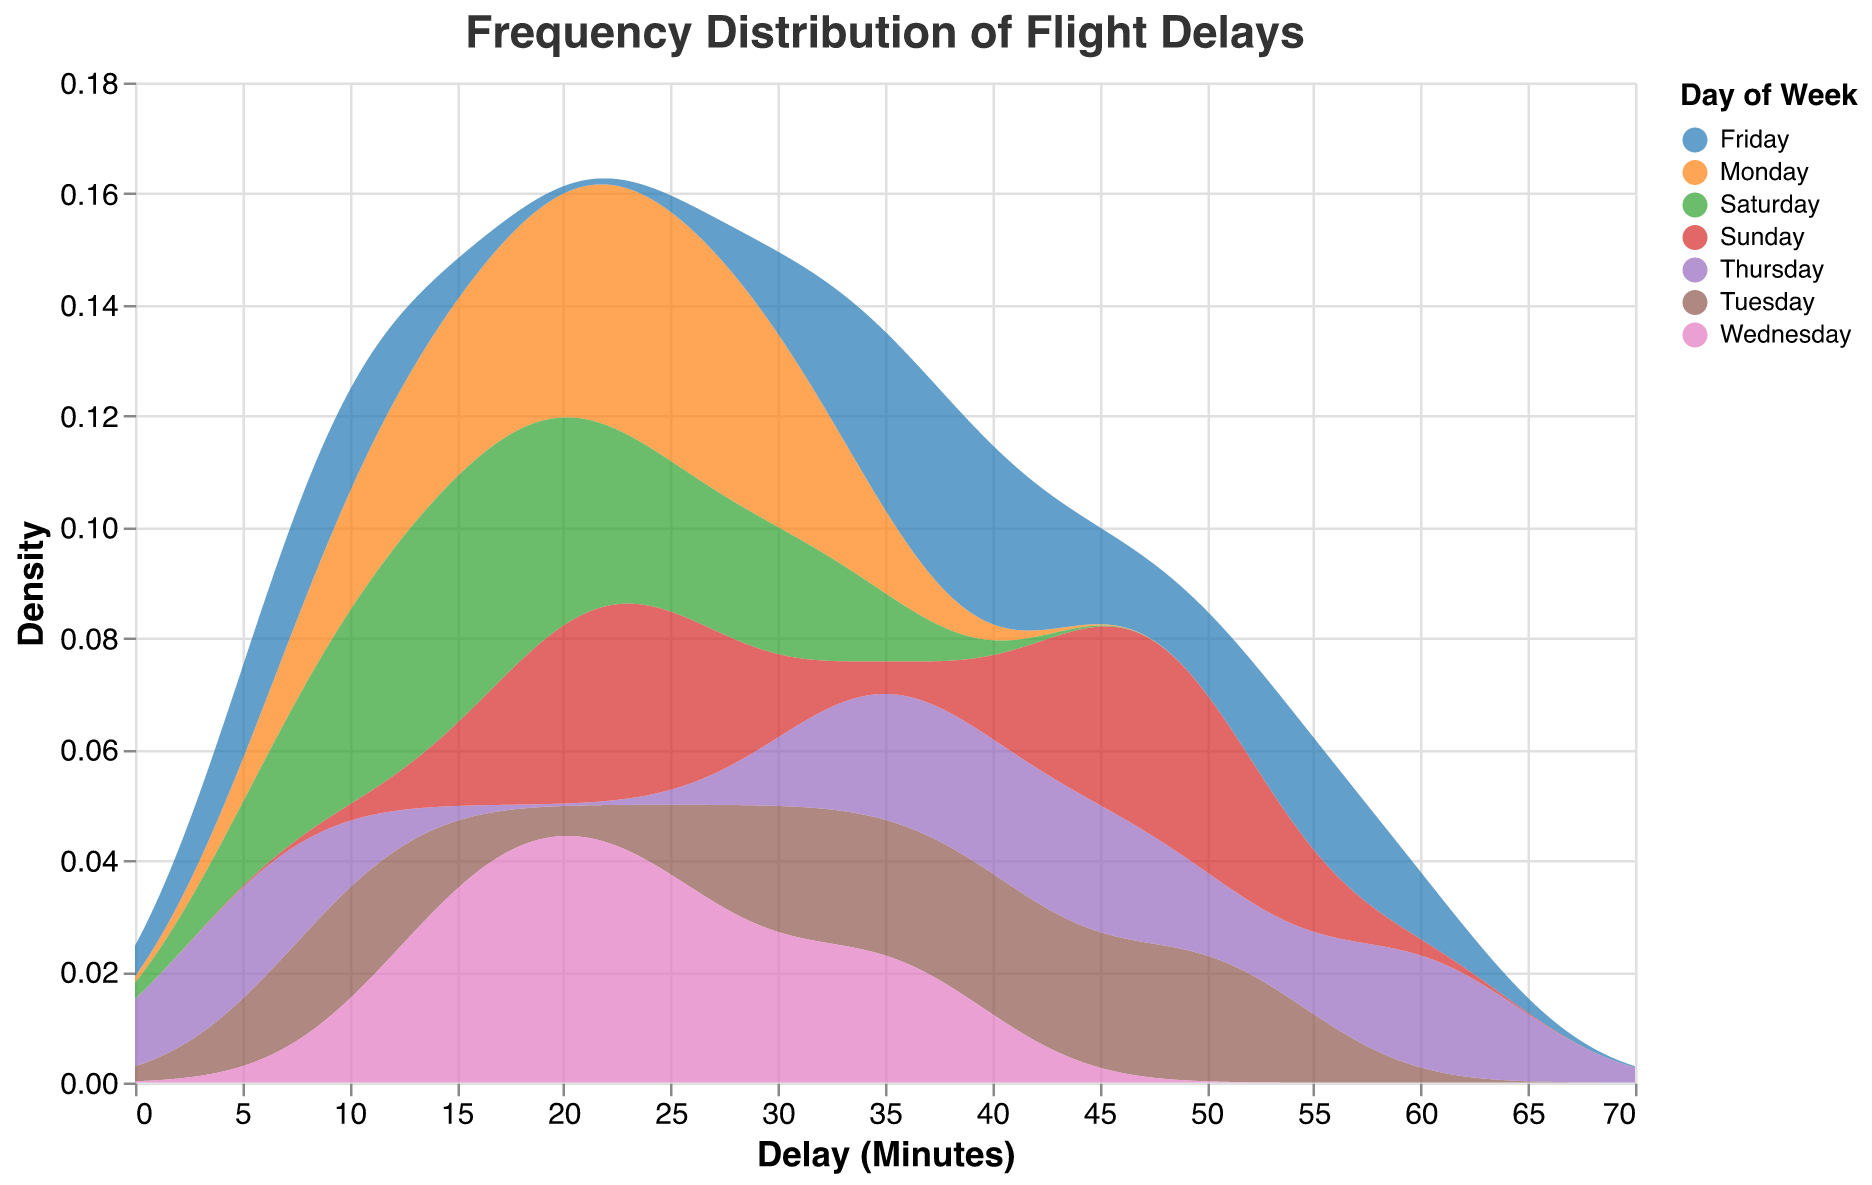What is the title of the figure? The title is located at the top of the figure, typically displaying a summary of what the figure represents.
Answer: Frequency Distribution of Flight Delays How many different days of the week are represented in the figure? The legend provides information on the categories represented in the plot. Each unique color corresponds to a different day of the week.
Answer: Seven Which day of the week has the highest peak in delay density? By observing the height of the density curves, we can identify which day has the highest peak.
Answer: Thursday What is the range of delay minutes represented on the x-axis? The x-axis is labeled "Delay (Minutes)" and typically displays the minimum and maximum values at the extremities of the axis.
Answer: 0 to 70 Which day has the most frequent occurrence of a 20-minute delay? Look for the highest density value at the 20-minute mark along the x-axis across the different days' density plots.
Answer: Monday Between Friday and Sunday, which day shows a higher density for delays around 45 minutes? Comparing the density values at the 45-minute mark for both Fridays and Sundays will indicate which has a higher density.
Answer: Sunday In terms of density, which day has the smallest peak in delay distribution? The day with the lowest maximum density value on the y-axis will have the smallest peak.
Answer: Thursday How does the density of delays around 10 minutes on Wednesday compare to that on Monday? Examine the height of the curves at the 10-minute mark for both days, noting which one is higher.
Answer: Wednesday has a higher density What is the color associated with Sunday in the figure's legend? The legend assigns specific colors to each day of the week, which can be identified by looking at the color scheme.
Answer: Orange (based on common color schemes) Do delay densities tend to be higher in the morning or in the evening across all days? Although the specific times are not directly visible, general peaks can imply whether delays are more common in morning or evening for each day.
Answer: Evening 